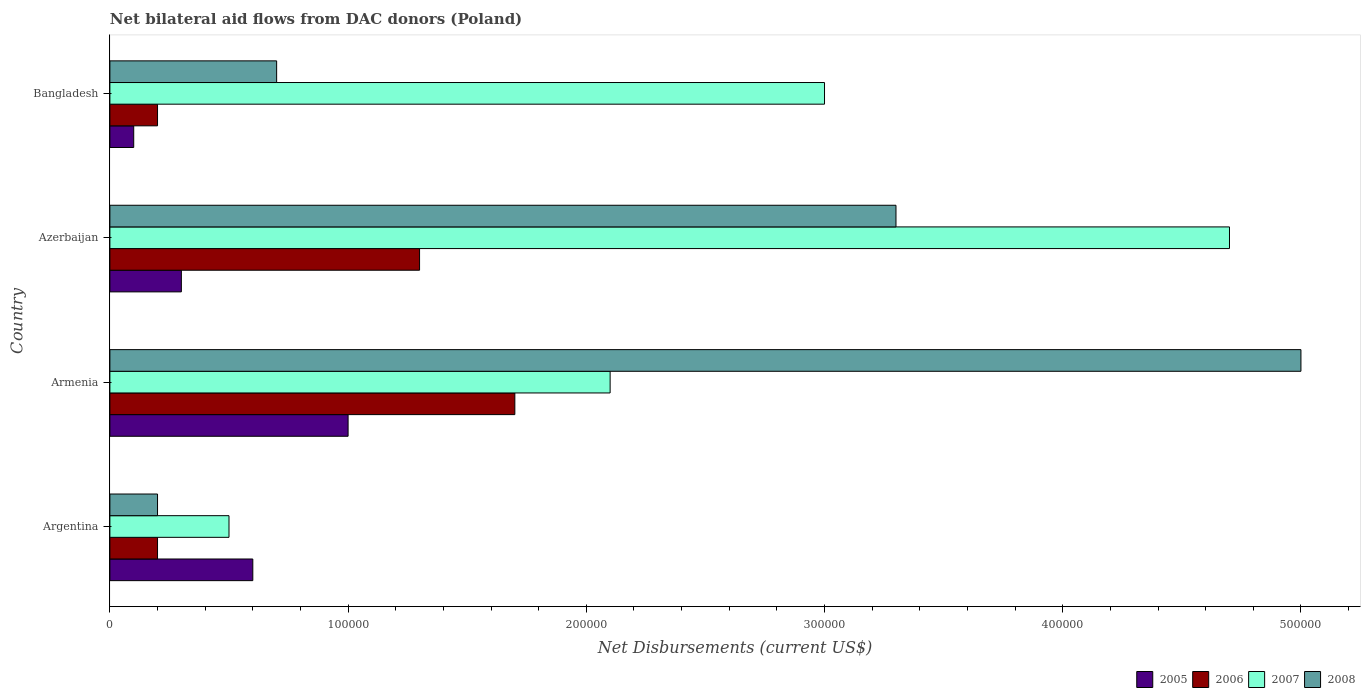How many groups of bars are there?
Provide a short and direct response. 4. How many bars are there on the 2nd tick from the top?
Provide a succinct answer. 4. How many bars are there on the 1st tick from the bottom?
Make the answer very short. 4. What is the label of the 4th group of bars from the top?
Provide a short and direct response. Argentina. What is the net bilateral aid flows in 2008 in Bangladesh?
Your answer should be compact. 7.00e+04. Across all countries, what is the maximum net bilateral aid flows in 2007?
Offer a terse response. 4.70e+05. Across all countries, what is the minimum net bilateral aid flows in 2007?
Offer a terse response. 5.00e+04. In which country was the net bilateral aid flows in 2006 maximum?
Provide a succinct answer. Armenia. What is the average net bilateral aid flows in 2008 per country?
Provide a succinct answer. 2.30e+05. In how many countries, is the net bilateral aid flows in 2005 greater than 240000 US$?
Ensure brevity in your answer.  0. What is the ratio of the net bilateral aid flows in 2007 in Argentina to that in Bangladesh?
Offer a very short reply. 0.17. Is the net bilateral aid flows in 2005 in Armenia less than that in Azerbaijan?
Provide a succinct answer. No. Is it the case that in every country, the sum of the net bilateral aid flows in 2005 and net bilateral aid flows in 2007 is greater than the sum of net bilateral aid flows in 2006 and net bilateral aid flows in 2008?
Ensure brevity in your answer.  No. What does the 1st bar from the top in Argentina represents?
Ensure brevity in your answer.  2008. How many bars are there?
Your answer should be very brief. 16. How many countries are there in the graph?
Your answer should be compact. 4. What is the difference between two consecutive major ticks on the X-axis?
Provide a succinct answer. 1.00e+05. Are the values on the major ticks of X-axis written in scientific E-notation?
Offer a very short reply. No. Does the graph contain any zero values?
Your response must be concise. No. Does the graph contain grids?
Offer a very short reply. No. How many legend labels are there?
Keep it short and to the point. 4. What is the title of the graph?
Ensure brevity in your answer.  Net bilateral aid flows from DAC donors (Poland). What is the label or title of the X-axis?
Ensure brevity in your answer.  Net Disbursements (current US$). What is the label or title of the Y-axis?
Your answer should be very brief. Country. What is the Net Disbursements (current US$) in 2006 in Armenia?
Offer a terse response. 1.70e+05. What is the Net Disbursements (current US$) in 2007 in Armenia?
Your answer should be very brief. 2.10e+05. What is the Net Disbursements (current US$) of 2005 in Azerbaijan?
Provide a short and direct response. 3.00e+04. What is the Net Disbursements (current US$) in 2006 in Azerbaijan?
Your answer should be very brief. 1.30e+05. What is the Net Disbursements (current US$) of 2007 in Azerbaijan?
Offer a very short reply. 4.70e+05. What is the Net Disbursements (current US$) of 2008 in Azerbaijan?
Make the answer very short. 3.30e+05. What is the Net Disbursements (current US$) of 2006 in Bangladesh?
Offer a very short reply. 2.00e+04. What is the Net Disbursements (current US$) in 2007 in Bangladesh?
Give a very brief answer. 3.00e+05. Across all countries, what is the minimum Net Disbursements (current US$) of 2005?
Give a very brief answer. 10000. Across all countries, what is the minimum Net Disbursements (current US$) of 2006?
Keep it short and to the point. 2.00e+04. What is the total Net Disbursements (current US$) of 2006 in the graph?
Provide a short and direct response. 3.40e+05. What is the total Net Disbursements (current US$) of 2007 in the graph?
Keep it short and to the point. 1.03e+06. What is the total Net Disbursements (current US$) in 2008 in the graph?
Your answer should be very brief. 9.20e+05. What is the difference between the Net Disbursements (current US$) of 2007 in Argentina and that in Armenia?
Make the answer very short. -1.60e+05. What is the difference between the Net Disbursements (current US$) in 2008 in Argentina and that in Armenia?
Offer a terse response. -4.80e+05. What is the difference between the Net Disbursements (current US$) in 2006 in Argentina and that in Azerbaijan?
Your answer should be compact. -1.10e+05. What is the difference between the Net Disbursements (current US$) in 2007 in Argentina and that in Azerbaijan?
Make the answer very short. -4.20e+05. What is the difference between the Net Disbursements (current US$) in 2008 in Argentina and that in Azerbaijan?
Your answer should be compact. -3.10e+05. What is the difference between the Net Disbursements (current US$) of 2005 in Argentina and that in Bangladesh?
Your answer should be very brief. 5.00e+04. What is the difference between the Net Disbursements (current US$) in 2007 in Argentina and that in Bangladesh?
Provide a short and direct response. -2.50e+05. What is the difference between the Net Disbursements (current US$) of 2008 in Argentina and that in Bangladesh?
Your answer should be compact. -5.00e+04. What is the difference between the Net Disbursements (current US$) in 2006 in Armenia and that in Azerbaijan?
Your answer should be compact. 4.00e+04. What is the difference between the Net Disbursements (current US$) in 2007 in Armenia and that in Azerbaijan?
Provide a succinct answer. -2.60e+05. What is the difference between the Net Disbursements (current US$) in 2008 in Armenia and that in Azerbaijan?
Provide a succinct answer. 1.70e+05. What is the difference between the Net Disbursements (current US$) in 2007 in Armenia and that in Bangladesh?
Ensure brevity in your answer.  -9.00e+04. What is the difference between the Net Disbursements (current US$) in 2005 in Azerbaijan and that in Bangladesh?
Provide a short and direct response. 2.00e+04. What is the difference between the Net Disbursements (current US$) in 2006 in Azerbaijan and that in Bangladesh?
Ensure brevity in your answer.  1.10e+05. What is the difference between the Net Disbursements (current US$) of 2005 in Argentina and the Net Disbursements (current US$) of 2006 in Armenia?
Your answer should be very brief. -1.10e+05. What is the difference between the Net Disbursements (current US$) in 2005 in Argentina and the Net Disbursements (current US$) in 2007 in Armenia?
Your answer should be compact. -1.50e+05. What is the difference between the Net Disbursements (current US$) in 2005 in Argentina and the Net Disbursements (current US$) in 2008 in Armenia?
Offer a terse response. -4.40e+05. What is the difference between the Net Disbursements (current US$) of 2006 in Argentina and the Net Disbursements (current US$) of 2008 in Armenia?
Your answer should be very brief. -4.80e+05. What is the difference between the Net Disbursements (current US$) of 2007 in Argentina and the Net Disbursements (current US$) of 2008 in Armenia?
Offer a terse response. -4.50e+05. What is the difference between the Net Disbursements (current US$) in 2005 in Argentina and the Net Disbursements (current US$) in 2006 in Azerbaijan?
Give a very brief answer. -7.00e+04. What is the difference between the Net Disbursements (current US$) of 2005 in Argentina and the Net Disbursements (current US$) of 2007 in Azerbaijan?
Your answer should be compact. -4.10e+05. What is the difference between the Net Disbursements (current US$) in 2005 in Argentina and the Net Disbursements (current US$) in 2008 in Azerbaijan?
Make the answer very short. -2.70e+05. What is the difference between the Net Disbursements (current US$) of 2006 in Argentina and the Net Disbursements (current US$) of 2007 in Azerbaijan?
Offer a very short reply. -4.50e+05. What is the difference between the Net Disbursements (current US$) of 2006 in Argentina and the Net Disbursements (current US$) of 2008 in Azerbaijan?
Ensure brevity in your answer.  -3.10e+05. What is the difference between the Net Disbursements (current US$) of 2007 in Argentina and the Net Disbursements (current US$) of 2008 in Azerbaijan?
Your response must be concise. -2.80e+05. What is the difference between the Net Disbursements (current US$) of 2006 in Argentina and the Net Disbursements (current US$) of 2007 in Bangladesh?
Provide a short and direct response. -2.80e+05. What is the difference between the Net Disbursements (current US$) in 2007 in Argentina and the Net Disbursements (current US$) in 2008 in Bangladesh?
Offer a very short reply. -2.00e+04. What is the difference between the Net Disbursements (current US$) of 2005 in Armenia and the Net Disbursements (current US$) of 2007 in Azerbaijan?
Your answer should be very brief. -3.70e+05. What is the difference between the Net Disbursements (current US$) in 2006 in Armenia and the Net Disbursements (current US$) in 2008 in Azerbaijan?
Your response must be concise. -1.60e+05. What is the difference between the Net Disbursements (current US$) of 2007 in Armenia and the Net Disbursements (current US$) of 2008 in Azerbaijan?
Offer a terse response. -1.20e+05. What is the difference between the Net Disbursements (current US$) of 2005 in Armenia and the Net Disbursements (current US$) of 2006 in Bangladesh?
Make the answer very short. 8.00e+04. What is the difference between the Net Disbursements (current US$) in 2005 in Armenia and the Net Disbursements (current US$) in 2007 in Bangladesh?
Your answer should be very brief. -2.00e+05. What is the difference between the Net Disbursements (current US$) of 2005 in Armenia and the Net Disbursements (current US$) of 2008 in Bangladesh?
Your response must be concise. 3.00e+04. What is the difference between the Net Disbursements (current US$) of 2006 in Armenia and the Net Disbursements (current US$) of 2007 in Bangladesh?
Give a very brief answer. -1.30e+05. What is the difference between the Net Disbursements (current US$) in 2006 in Armenia and the Net Disbursements (current US$) in 2008 in Bangladesh?
Give a very brief answer. 1.00e+05. What is the difference between the Net Disbursements (current US$) in 2007 in Armenia and the Net Disbursements (current US$) in 2008 in Bangladesh?
Keep it short and to the point. 1.40e+05. What is the difference between the Net Disbursements (current US$) of 2005 in Azerbaijan and the Net Disbursements (current US$) of 2008 in Bangladesh?
Offer a terse response. -4.00e+04. What is the average Net Disbursements (current US$) in 2006 per country?
Ensure brevity in your answer.  8.50e+04. What is the average Net Disbursements (current US$) of 2007 per country?
Keep it short and to the point. 2.58e+05. What is the difference between the Net Disbursements (current US$) in 2005 and Net Disbursements (current US$) in 2007 in Argentina?
Give a very brief answer. 10000. What is the difference between the Net Disbursements (current US$) of 2006 and Net Disbursements (current US$) of 2007 in Argentina?
Your answer should be very brief. -3.00e+04. What is the difference between the Net Disbursements (current US$) in 2006 and Net Disbursements (current US$) in 2008 in Argentina?
Ensure brevity in your answer.  0. What is the difference between the Net Disbursements (current US$) in 2007 and Net Disbursements (current US$) in 2008 in Argentina?
Your answer should be compact. 3.00e+04. What is the difference between the Net Disbursements (current US$) in 2005 and Net Disbursements (current US$) in 2006 in Armenia?
Provide a succinct answer. -7.00e+04. What is the difference between the Net Disbursements (current US$) in 2005 and Net Disbursements (current US$) in 2007 in Armenia?
Your answer should be compact. -1.10e+05. What is the difference between the Net Disbursements (current US$) of 2005 and Net Disbursements (current US$) of 2008 in Armenia?
Give a very brief answer. -4.00e+05. What is the difference between the Net Disbursements (current US$) in 2006 and Net Disbursements (current US$) in 2007 in Armenia?
Keep it short and to the point. -4.00e+04. What is the difference between the Net Disbursements (current US$) in 2006 and Net Disbursements (current US$) in 2008 in Armenia?
Your answer should be compact. -3.30e+05. What is the difference between the Net Disbursements (current US$) of 2005 and Net Disbursements (current US$) of 2007 in Azerbaijan?
Make the answer very short. -4.40e+05. What is the difference between the Net Disbursements (current US$) of 2007 and Net Disbursements (current US$) of 2008 in Azerbaijan?
Offer a very short reply. 1.40e+05. What is the difference between the Net Disbursements (current US$) of 2005 and Net Disbursements (current US$) of 2006 in Bangladesh?
Provide a succinct answer. -10000. What is the difference between the Net Disbursements (current US$) in 2005 and Net Disbursements (current US$) in 2007 in Bangladesh?
Offer a very short reply. -2.90e+05. What is the difference between the Net Disbursements (current US$) in 2006 and Net Disbursements (current US$) in 2007 in Bangladesh?
Offer a very short reply. -2.80e+05. What is the difference between the Net Disbursements (current US$) in 2006 and Net Disbursements (current US$) in 2008 in Bangladesh?
Your response must be concise. -5.00e+04. What is the difference between the Net Disbursements (current US$) in 2007 and Net Disbursements (current US$) in 2008 in Bangladesh?
Offer a terse response. 2.30e+05. What is the ratio of the Net Disbursements (current US$) in 2005 in Argentina to that in Armenia?
Make the answer very short. 0.6. What is the ratio of the Net Disbursements (current US$) in 2006 in Argentina to that in Armenia?
Give a very brief answer. 0.12. What is the ratio of the Net Disbursements (current US$) of 2007 in Argentina to that in Armenia?
Provide a succinct answer. 0.24. What is the ratio of the Net Disbursements (current US$) in 2008 in Argentina to that in Armenia?
Keep it short and to the point. 0.04. What is the ratio of the Net Disbursements (current US$) in 2005 in Argentina to that in Azerbaijan?
Keep it short and to the point. 2. What is the ratio of the Net Disbursements (current US$) of 2006 in Argentina to that in Azerbaijan?
Keep it short and to the point. 0.15. What is the ratio of the Net Disbursements (current US$) in 2007 in Argentina to that in Azerbaijan?
Make the answer very short. 0.11. What is the ratio of the Net Disbursements (current US$) in 2008 in Argentina to that in Azerbaijan?
Keep it short and to the point. 0.06. What is the ratio of the Net Disbursements (current US$) in 2006 in Argentina to that in Bangladesh?
Offer a very short reply. 1. What is the ratio of the Net Disbursements (current US$) of 2007 in Argentina to that in Bangladesh?
Ensure brevity in your answer.  0.17. What is the ratio of the Net Disbursements (current US$) of 2008 in Argentina to that in Bangladesh?
Offer a terse response. 0.29. What is the ratio of the Net Disbursements (current US$) in 2006 in Armenia to that in Azerbaijan?
Provide a succinct answer. 1.31. What is the ratio of the Net Disbursements (current US$) in 2007 in Armenia to that in Azerbaijan?
Your answer should be very brief. 0.45. What is the ratio of the Net Disbursements (current US$) in 2008 in Armenia to that in Azerbaijan?
Ensure brevity in your answer.  1.52. What is the ratio of the Net Disbursements (current US$) of 2008 in Armenia to that in Bangladesh?
Ensure brevity in your answer.  7.14. What is the ratio of the Net Disbursements (current US$) of 2005 in Azerbaijan to that in Bangladesh?
Offer a very short reply. 3. What is the ratio of the Net Disbursements (current US$) of 2006 in Azerbaijan to that in Bangladesh?
Your answer should be compact. 6.5. What is the ratio of the Net Disbursements (current US$) of 2007 in Azerbaijan to that in Bangladesh?
Offer a very short reply. 1.57. What is the ratio of the Net Disbursements (current US$) in 2008 in Azerbaijan to that in Bangladesh?
Keep it short and to the point. 4.71. What is the difference between the highest and the second highest Net Disbursements (current US$) in 2005?
Provide a short and direct response. 4.00e+04. What is the difference between the highest and the second highest Net Disbursements (current US$) in 2007?
Offer a very short reply. 1.70e+05. What is the difference between the highest and the second highest Net Disbursements (current US$) of 2008?
Offer a very short reply. 1.70e+05. What is the difference between the highest and the lowest Net Disbursements (current US$) of 2005?
Your response must be concise. 9.00e+04. What is the difference between the highest and the lowest Net Disbursements (current US$) in 2008?
Make the answer very short. 4.80e+05. 